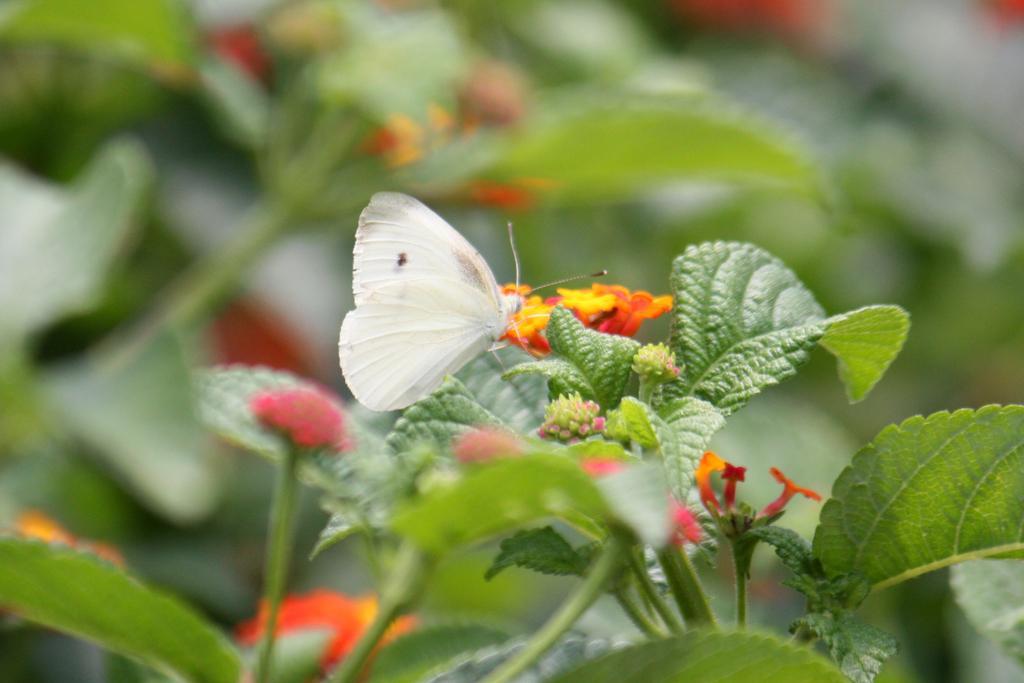Can you describe this image briefly? In this image we can see a butterfly on the leaf, there are plants, and flowers, also the background is blurred. 